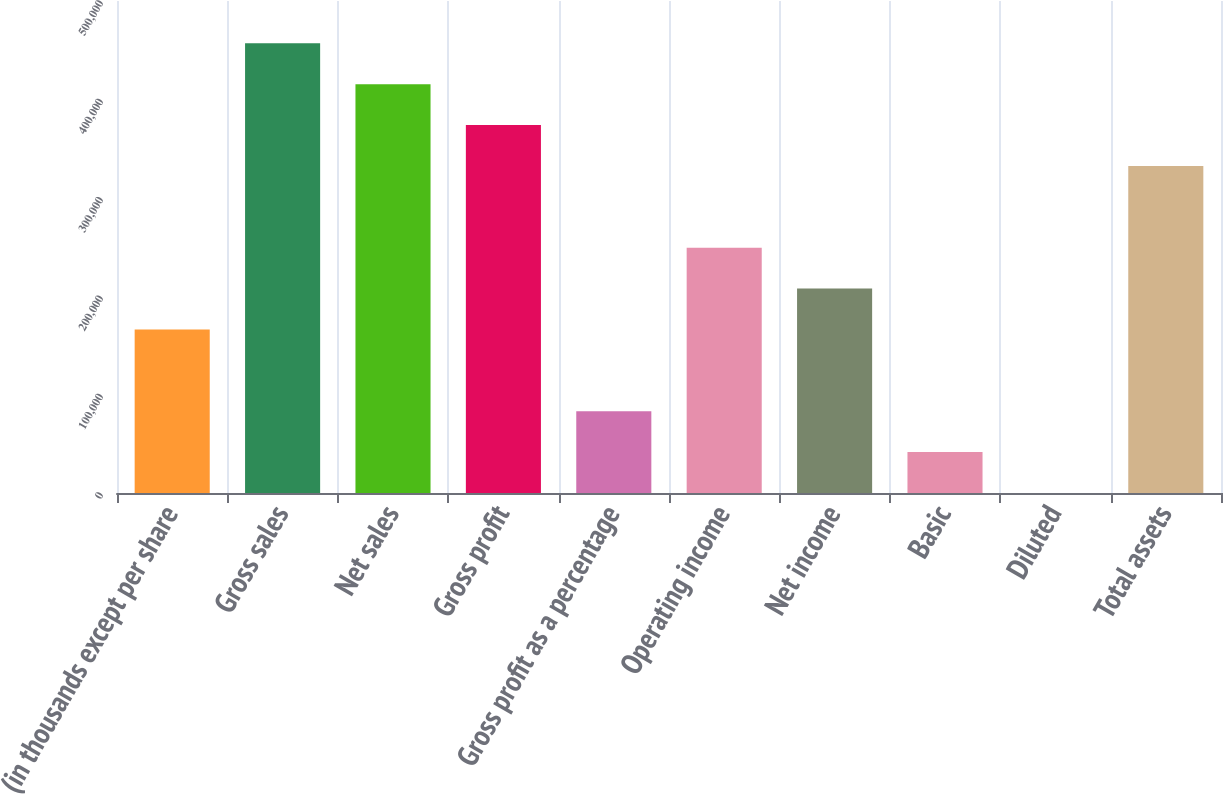Convert chart to OTSL. <chart><loc_0><loc_0><loc_500><loc_500><bar_chart><fcel>(in thousands except per share<fcel>Gross sales<fcel>Net sales<fcel>Gross profit<fcel>Gross profit as a percentage<fcel>Operating income<fcel>Net income<fcel>Basic<fcel>Diluted<fcel>Total assets<nl><fcel>166167<fcel>456959<fcel>415417<fcel>373875<fcel>83083.9<fcel>249250<fcel>207709<fcel>41542.3<fcel>0.65<fcel>332334<nl></chart> 